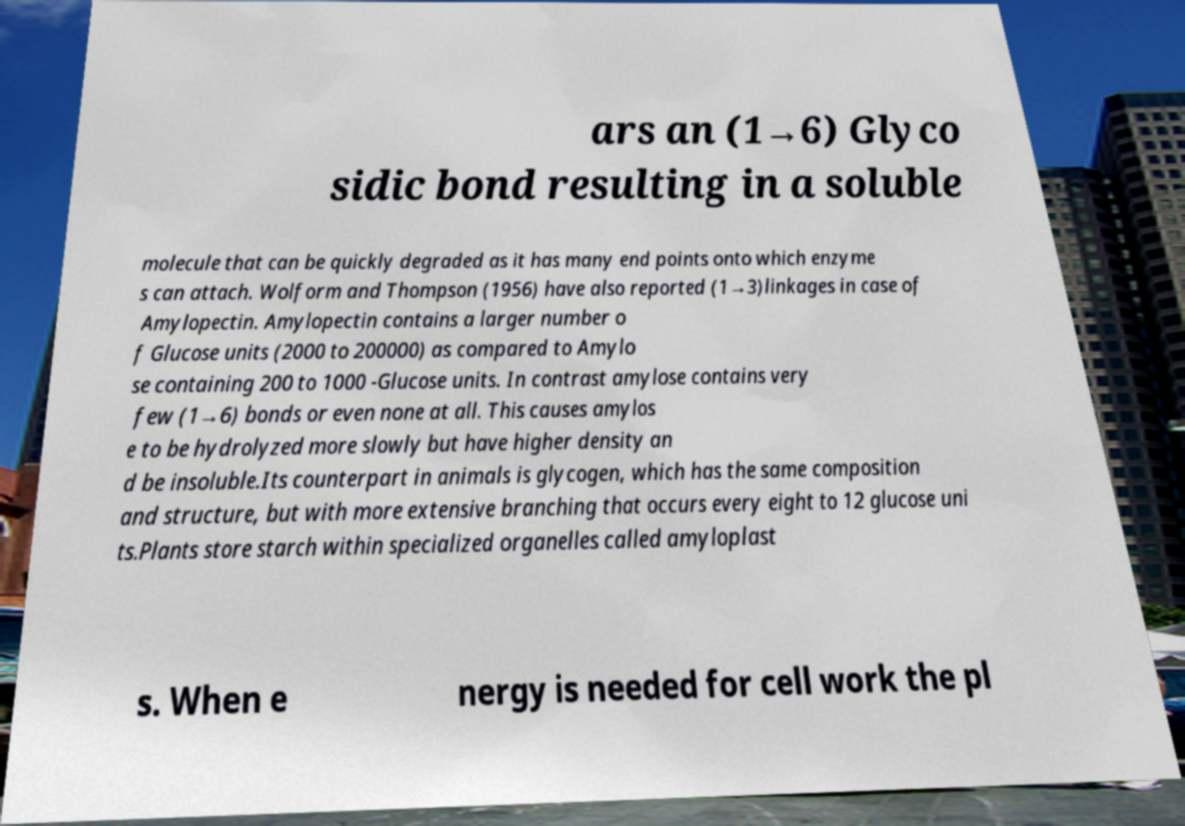Can you read and provide the text displayed in the image?This photo seems to have some interesting text. Can you extract and type it out for me? ars an (1→6) Glyco sidic bond resulting in a soluble molecule that can be quickly degraded as it has many end points onto which enzyme s can attach. Wolform and Thompson (1956) have also reported (1→3)linkages in case of Amylopectin. Amylopectin contains a larger number o f Glucose units (2000 to 200000) as compared to Amylo se containing 200 to 1000 -Glucose units. In contrast amylose contains very few (1→6) bonds or even none at all. This causes amylos e to be hydrolyzed more slowly but have higher density an d be insoluble.Its counterpart in animals is glycogen, which has the same composition and structure, but with more extensive branching that occurs every eight to 12 glucose uni ts.Plants store starch within specialized organelles called amyloplast s. When e nergy is needed for cell work the pl 